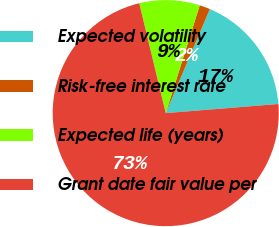<chart> <loc_0><loc_0><loc_500><loc_500><pie_chart><fcel>Expected volatility<fcel>Risk-free interest rate<fcel>Expected life (years)<fcel>Grant date fair value per<nl><fcel>17.33%<fcel>1.52%<fcel>8.63%<fcel>72.52%<nl></chart> 